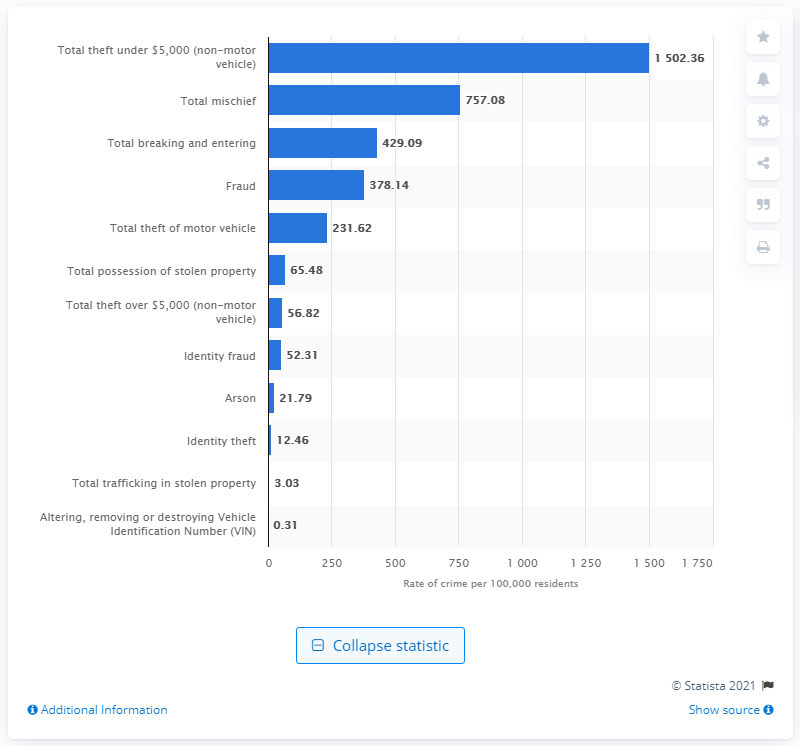Are there any significant differences in the rate of property-related crimes compared to fraud-related crimes? According to the bar chart, property-related crimes like 'Total theft under $5,000 (non-motor vehicle)' and 'Total breaking and entering' have much higher rates of 1,502.36 and 429.09 respectively, per 100,000 residents. In contrast, fraud-related crimes such as 'Fraud' and 'Identity fraud' have lower rates of 378.14 and 52.31 per 100,000 residents in Canada for 2019. This discrepancy highlights that, while both are significant concerns, property-related crimes were reported more frequently than fraud-related crimes in that year. 